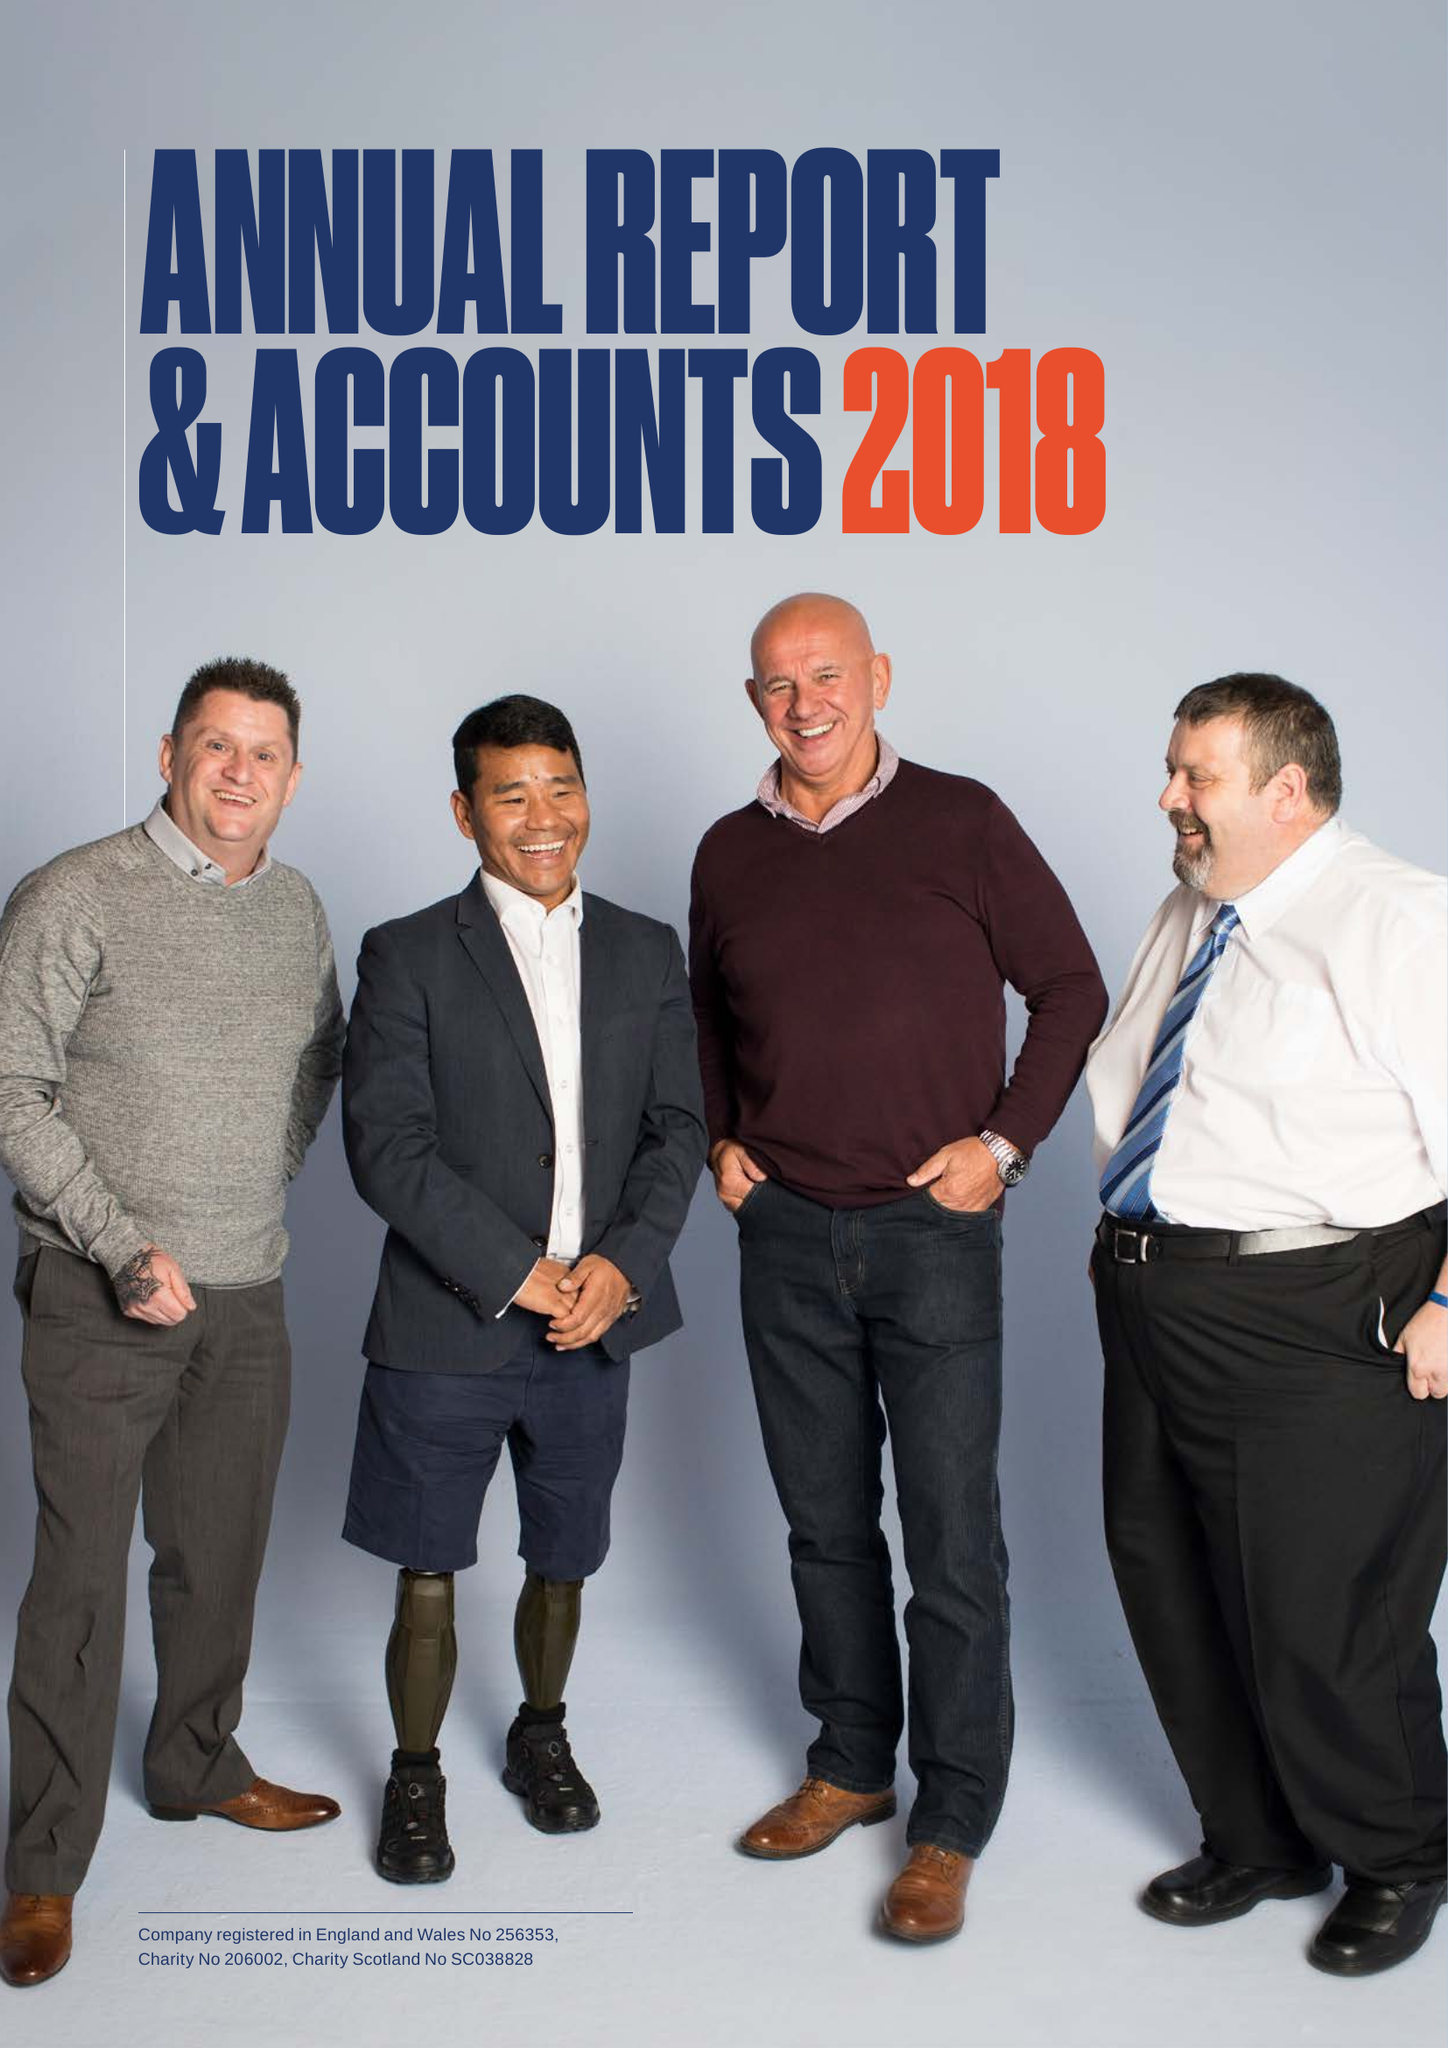What is the value for the report_date?
Answer the question using a single word or phrase. 2018-03-31 